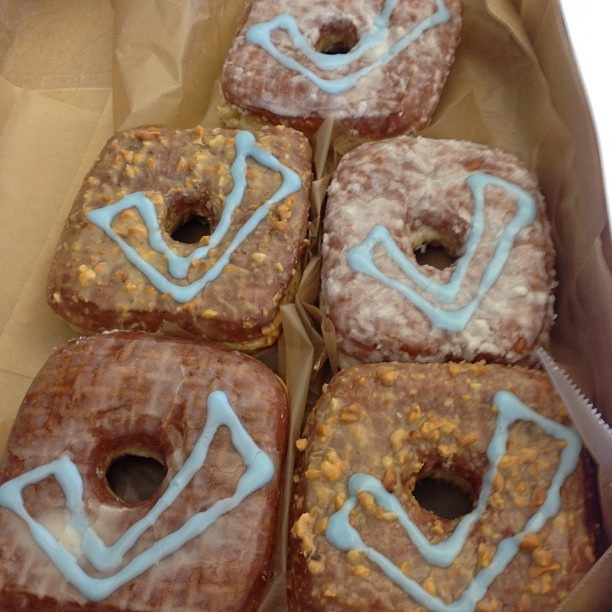Describe the objects in this image and their specific colors. I can see donut in gray, brown, and darkgray tones, donut in gray, darkgray, and maroon tones, donut in gray and darkgray tones, donut in gray, tan, maroon, and brown tones, and donut in gray, darkgray, and maroon tones in this image. 